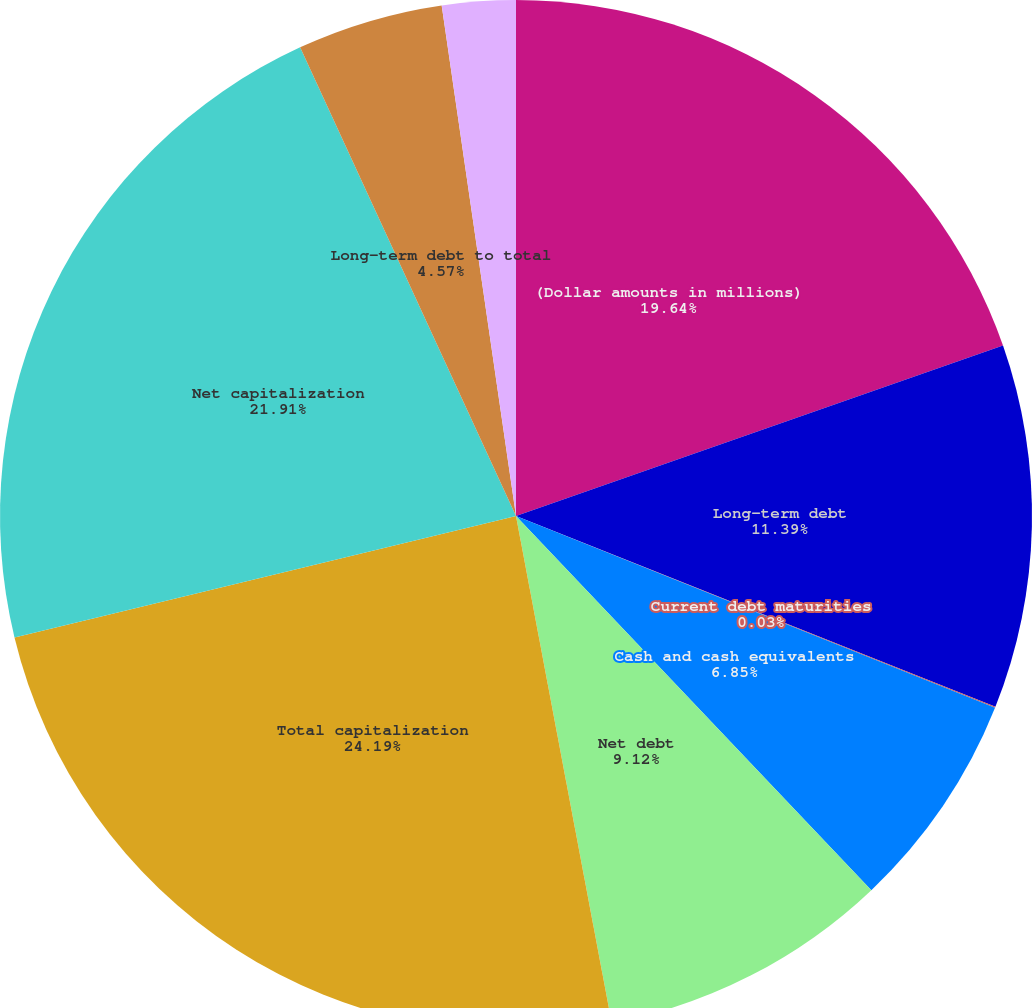<chart> <loc_0><loc_0><loc_500><loc_500><pie_chart><fcel>(Dollar amounts in millions)<fcel>Long-term debt<fcel>Current debt maturities<fcel>Cash and cash equivalents<fcel>Net debt<fcel>Total capitalization<fcel>Net capitalization<fcel>Long-term debt to total<fcel>Net debt to net capitalization<nl><fcel>19.64%<fcel>11.39%<fcel>0.03%<fcel>6.85%<fcel>9.12%<fcel>24.19%<fcel>21.91%<fcel>4.57%<fcel>2.3%<nl></chart> 